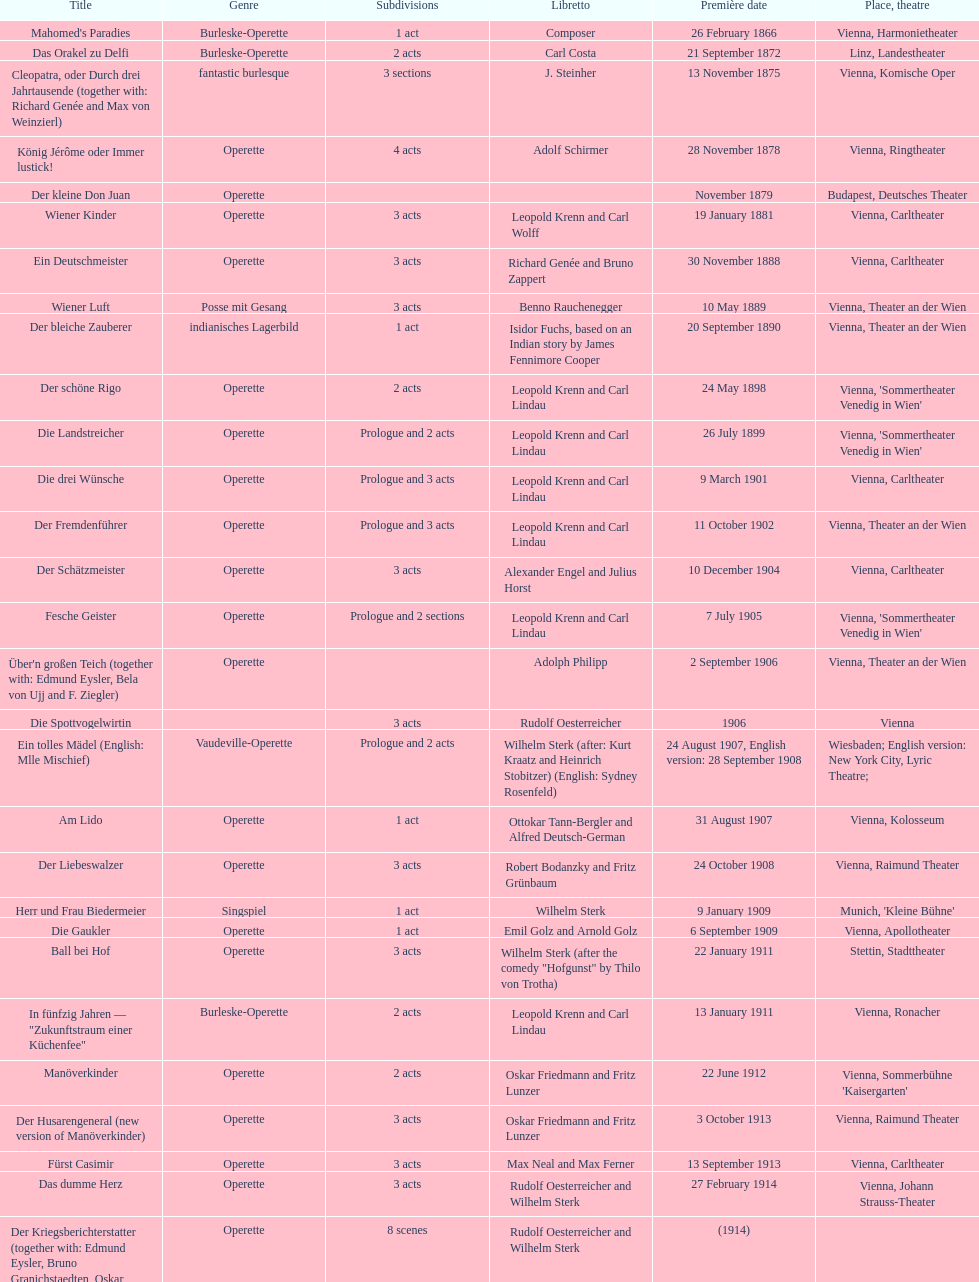Would you be able to parse every entry in this table? {'header': ['Title', 'Genre', 'Sub\xaddivisions', 'Libretto', 'Première date', 'Place, theatre'], 'rows': [["Mahomed's Paradies", 'Burleske-Operette', '1 act', 'Composer', '26 February 1866', 'Vienna, Harmonietheater'], ['Das Orakel zu Delfi', 'Burleske-Operette', '2 acts', 'Carl Costa', '21 September 1872', 'Linz, Landestheater'], ['Cleopatra, oder Durch drei Jahrtausende (together with: Richard Genée and Max von Weinzierl)', 'fantastic burlesque', '3 sections', 'J. Steinher', '13 November 1875', 'Vienna, Komische Oper'], ['König Jérôme oder Immer lustick!', 'Operette', '4 acts', 'Adolf Schirmer', '28 November 1878', 'Vienna, Ringtheater'], ['Der kleine Don Juan', 'Operette', '', '', 'November 1879', 'Budapest, Deutsches Theater'], ['Wiener Kinder', 'Operette', '3 acts', 'Leopold Krenn and Carl Wolff', '19 January 1881', 'Vienna, Carltheater'], ['Ein Deutschmeister', 'Operette', '3 acts', 'Richard Genée and Bruno Zappert', '30 November 1888', 'Vienna, Carltheater'], ['Wiener Luft', 'Posse mit Gesang', '3 acts', 'Benno Rauchenegger', '10 May 1889', 'Vienna, Theater an der Wien'], ['Der bleiche Zauberer', 'indianisches Lagerbild', '1 act', 'Isidor Fuchs, based on an Indian story by James Fennimore Cooper', '20 September 1890', 'Vienna, Theater an der Wien'], ['Der schöne Rigo', 'Operette', '2 acts', 'Leopold Krenn and Carl Lindau', '24 May 1898', "Vienna, 'Sommertheater Venedig in Wien'"], ['Die Landstreicher', 'Operette', 'Prologue and 2 acts', 'Leopold Krenn and Carl Lindau', '26 July 1899', "Vienna, 'Sommertheater Venedig in Wien'"], ['Die drei Wünsche', 'Operette', 'Prologue and 3 acts', 'Leopold Krenn and Carl Lindau', '9 March 1901', 'Vienna, Carltheater'], ['Der Fremdenführer', 'Operette', 'Prologue and 3 acts', 'Leopold Krenn and Carl Lindau', '11 October 1902', 'Vienna, Theater an der Wien'], ['Der Schätzmeister', 'Operette', '3 acts', 'Alexander Engel and Julius Horst', '10 December 1904', 'Vienna, Carltheater'], ['Fesche Geister', 'Operette', 'Prologue and 2 sections', 'Leopold Krenn and Carl Lindau', '7 July 1905', "Vienna, 'Sommertheater Venedig in Wien'"], ["Über'n großen Teich (together with: Edmund Eysler, Bela von Ujj and F. Ziegler)", 'Operette', '', 'Adolph Philipp', '2 September 1906', 'Vienna, Theater an der Wien'], ['Die Spottvogelwirtin', '', '3 acts', 'Rudolf Oesterreicher', '1906', 'Vienna'], ['Ein tolles Mädel (English: Mlle Mischief)', 'Vaudeville-Operette', 'Prologue and 2 acts', 'Wilhelm Sterk (after: Kurt Kraatz and Heinrich Stobitzer) (English: Sydney Rosenfeld)', '24 August 1907, English version: 28 September 1908', 'Wiesbaden; English version: New York City, Lyric Theatre;'], ['Am Lido', 'Operette', '1 act', 'Ottokar Tann-Bergler and Alfred Deutsch-German', '31 August 1907', 'Vienna, Kolosseum'], ['Der Liebeswalzer', 'Operette', '3 acts', 'Robert Bodanzky and Fritz Grünbaum', '24 October 1908', 'Vienna, Raimund Theater'], ['Herr und Frau Biedermeier', 'Singspiel', '1 act', 'Wilhelm Sterk', '9 January 1909', "Munich, 'Kleine Bühne'"], ['Die Gaukler', 'Operette', '1 act', 'Emil Golz and Arnold Golz', '6 September 1909', 'Vienna, Apollotheater'], ['Ball bei Hof', 'Operette', '3 acts', 'Wilhelm Sterk (after the comedy "Hofgunst" by Thilo von Trotha)', '22 January 1911', 'Stettin, Stadttheater'], ['In fünfzig Jahren — "Zukunftstraum einer Küchenfee"', 'Burleske-Operette', '2 acts', 'Leopold Krenn and Carl Lindau', '13 January 1911', 'Vienna, Ronacher'], ['Manöverkinder', 'Operette', '2 acts', 'Oskar Friedmann and Fritz Lunzer', '22 June 1912', "Vienna, Sommerbühne 'Kaisergarten'"], ['Der Husarengeneral (new version of Manöverkinder)', 'Operette', '3 acts', 'Oskar Friedmann and Fritz Lunzer', '3 October 1913', 'Vienna, Raimund Theater'], ['Fürst Casimir', 'Operette', '3 acts', 'Max Neal and Max Ferner', '13 September 1913', 'Vienna, Carltheater'], ['Das dumme Herz', 'Operette', '3 acts', 'Rudolf Oesterreicher and Wilhelm Sterk', '27 February 1914', 'Vienna, Johann Strauss-Theater'], ['Der Kriegsberichterstatter (together with: Edmund Eysler, Bruno Granichstaedten, Oskar Nedbal, Charles Weinberger)', 'Operette', '8 scenes', 'Rudolf Oesterreicher and Wilhelm Sterk', '(1914)', ''], ['Im siebenten Himmel', 'Operette', '3 acts', 'Max Neal and Max Ferner', '26 February 1916', 'Munich, Theater am Gärtnerplatz'], ['Deutschmeisterkapelle', 'Operette', '', 'Hubert Marischka and Rudolf Oesterreicher', '30 May 1958', 'Vienna, Raimund Theater'], ['Die verliebte Eskadron', 'Operette', '3 acts', 'Wilhelm Sterk (after B. Buchbinder)', '11 July 1930', 'Vienna, Johann-Strauß-Theater']]} In which urban center were the most operettas initially staged? Vienna. 